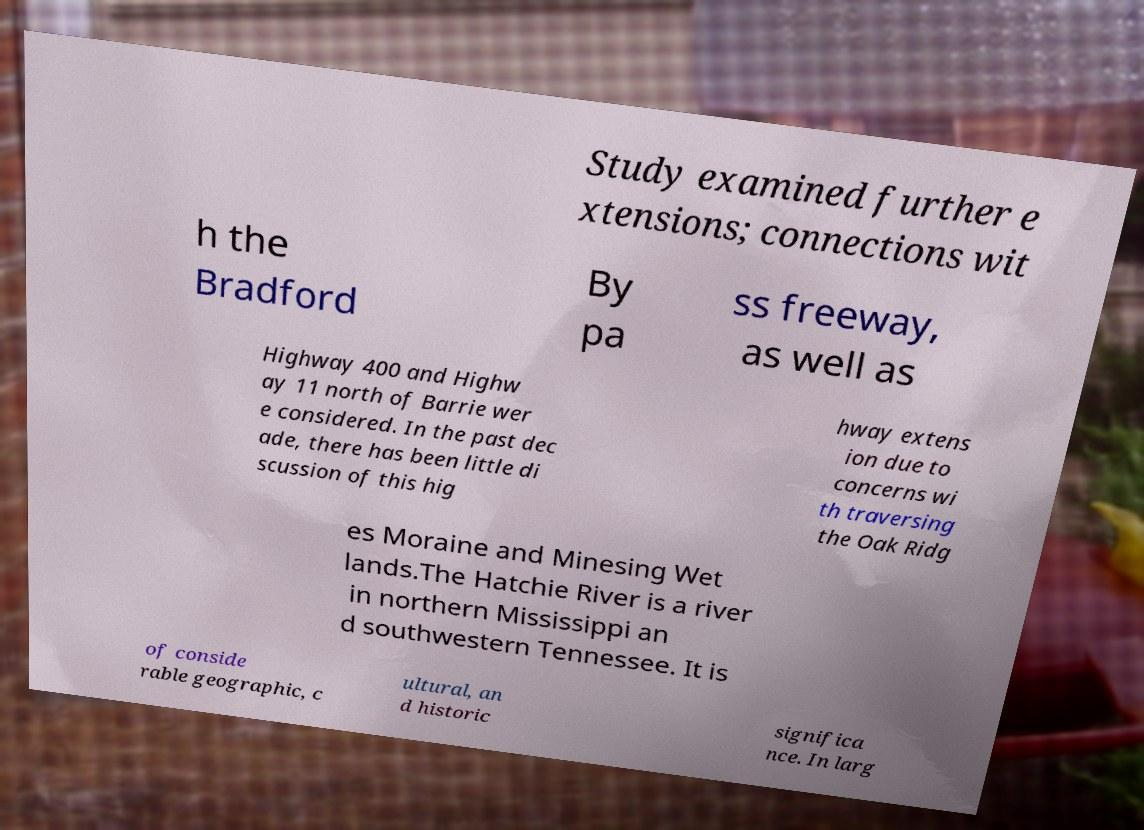Please read and relay the text visible in this image. What does it say? Study examined further e xtensions; connections wit h the Bradford By pa ss freeway, as well as Highway 400 and Highw ay 11 north of Barrie wer e considered. In the past dec ade, there has been little di scussion of this hig hway extens ion due to concerns wi th traversing the Oak Ridg es Moraine and Minesing Wet lands.The Hatchie River is a river in northern Mississippi an d southwestern Tennessee. It is of conside rable geographic, c ultural, an d historic significa nce. In larg 